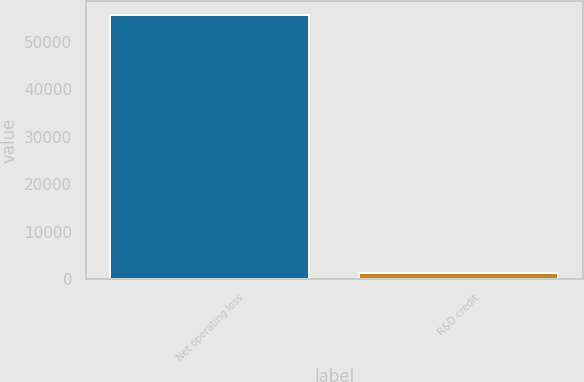<chart> <loc_0><loc_0><loc_500><loc_500><bar_chart><fcel>Net operating loss<fcel>R&D credit<nl><fcel>55665<fcel>1295<nl></chart> 